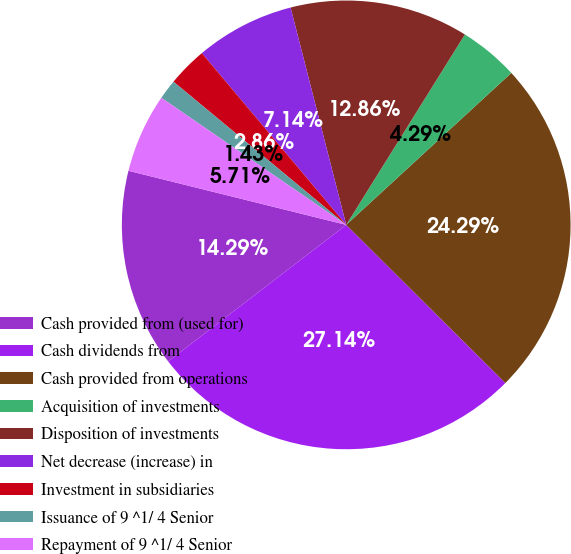Convert chart to OTSL. <chart><loc_0><loc_0><loc_500><loc_500><pie_chart><fcel>Cash provided from (used for)<fcel>Cash dividends from<fcel>Cash provided from operations<fcel>Acquisition of investments<fcel>Disposition of investments<fcel>Net decrease (increase) in<fcel>Investment in subsidiaries<fcel>Issuance of 9 ^1/ 4 Senior<fcel>Repayment of 9 ^1/ 4 Senior<nl><fcel>14.29%<fcel>27.14%<fcel>24.29%<fcel>4.29%<fcel>12.86%<fcel>7.14%<fcel>2.86%<fcel>1.43%<fcel>5.71%<nl></chart> 